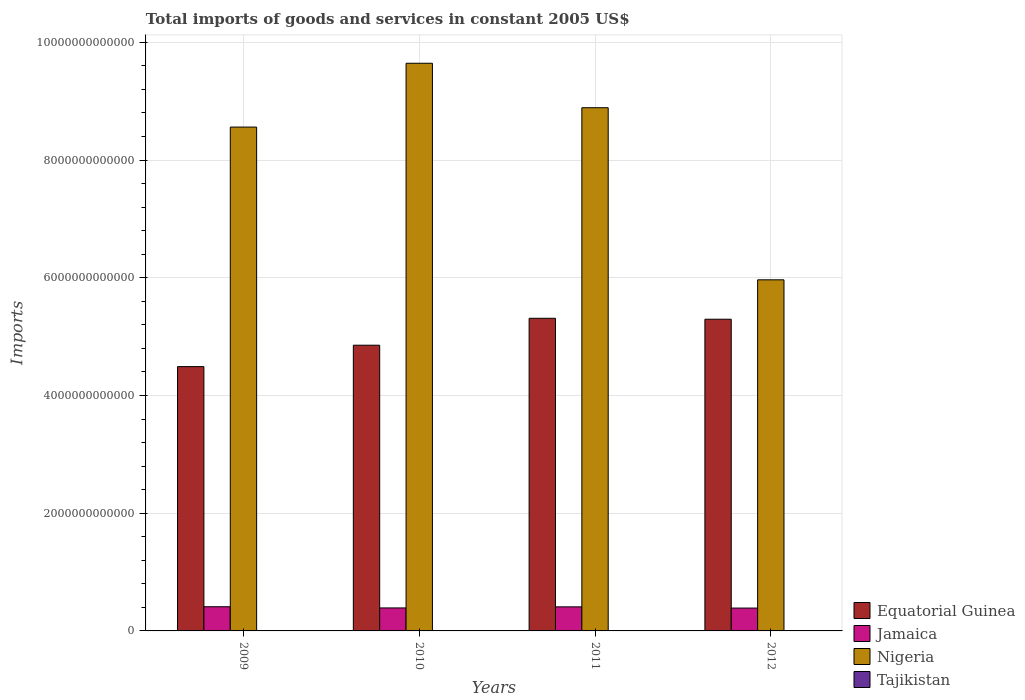How many different coloured bars are there?
Your answer should be very brief. 4. Are the number of bars per tick equal to the number of legend labels?
Make the answer very short. Yes. How many bars are there on the 1st tick from the left?
Offer a terse response. 4. What is the label of the 1st group of bars from the left?
Keep it short and to the point. 2009. What is the total imports of goods and services in Nigeria in 2009?
Provide a succinct answer. 8.56e+12. Across all years, what is the maximum total imports of goods and services in Equatorial Guinea?
Ensure brevity in your answer.  5.31e+12. Across all years, what is the minimum total imports of goods and services in Nigeria?
Make the answer very short. 5.97e+12. In which year was the total imports of goods and services in Jamaica maximum?
Your answer should be compact. 2009. What is the total total imports of goods and services in Tajikistan in the graph?
Make the answer very short. 1.70e+1. What is the difference between the total imports of goods and services in Jamaica in 2010 and that in 2011?
Provide a succinct answer. -1.83e+1. What is the difference between the total imports of goods and services in Nigeria in 2011 and the total imports of goods and services in Equatorial Guinea in 2010?
Offer a terse response. 4.03e+12. What is the average total imports of goods and services in Jamaica per year?
Give a very brief answer. 4.00e+11. In the year 2009, what is the difference between the total imports of goods and services in Equatorial Guinea and total imports of goods and services in Jamaica?
Your answer should be very brief. 4.08e+12. In how many years, is the total imports of goods and services in Nigeria greater than 6800000000000 US$?
Provide a succinct answer. 3. What is the ratio of the total imports of goods and services in Tajikistan in 2009 to that in 2010?
Keep it short and to the point. 0.93. Is the total imports of goods and services in Jamaica in 2009 less than that in 2011?
Provide a succinct answer. No. Is the difference between the total imports of goods and services in Equatorial Guinea in 2009 and 2010 greater than the difference between the total imports of goods and services in Jamaica in 2009 and 2010?
Make the answer very short. No. What is the difference between the highest and the second highest total imports of goods and services in Jamaica?
Provide a short and direct response. 1.80e+09. What is the difference between the highest and the lowest total imports of goods and services in Nigeria?
Your response must be concise. 3.68e+12. In how many years, is the total imports of goods and services in Jamaica greater than the average total imports of goods and services in Jamaica taken over all years?
Provide a succinct answer. 2. What does the 4th bar from the left in 2012 represents?
Offer a very short reply. Tajikistan. What does the 4th bar from the right in 2011 represents?
Make the answer very short. Equatorial Guinea. What is the difference between two consecutive major ticks on the Y-axis?
Your answer should be very brief. 2.00e+12. Where does the legend appear in the graph?
Your response must be concise. Bottom right. What is the title of the graph?
Your response must be concise. Total imports of goods and services in constant 2005 US$. What is the label or title of the X-axis?
Offer a very short reply. Years. What is the label or title of the Y-axis?
Ensure brevity in your answer.  Imports. What is the Imports in Equatorial Guinea in 2009?
Ensure brevity in your answer.  4.49e+12. What is the Imports in Jamaica in 2009?
Ensure brevity in your answer.  4.11e+11. What is the Imports of Nigeria in 2009?
Give a very brief answer. 8.56e+12. What is the Imports in Tajikistan in 2009?
Offer a very short reply. 3.83e+09. What is the Imports of Equatorial Guinea in 2010?
Provide a succinct answer. 4.85e+12. What is the Imports in Jamaica in 2010?
Offer a very short reply. 3.91e+11. What is the Imports in Nigeria in 2010?
Give a very brief answer. 9.64e+12. What is the Imports in Tajikistan in 2010?
Provide a succinct answer. 4.10e+09. What is the Imports of Equatorial Guinea in 2011?
Give a very brief answer. 5.31e+12. What is the Imports of Jamaica in 2011?
Your response must be concise. 4.09e+11. What is the Imports of Nigeria in 2011?
Make the answer very short. 8.89e+12. What is the Imports in Tajikistan in 2011?
Ensure brevity in your answer.  4.38e+09. What is the Imports in Equatorial Guinea in 2012?
Your answer should be very brief. 5.30e+12. What is the Imports in Jamaica in 2012?
Offer a terse response. 3.88e+11. What is the Imports in Nigeria in 2012?
Your response must be concise. 5.97e+12. What is the Imports of Tajikistan in 2012?
Keep it short and to the point. 4.65e+09. Across all years, what is the maximum Imports of Equatorial Guinea?
Ensure brevity in your answer.  5.31e+12. Across all years, what is the maximum Imports in Jamaica?
Keep it short and to the point. 4.11e+11. Across all years, what is the maximum Imports of Nigeria?
Provide a succinct answer. 9.64e+12. Across all years, what is the maximum Imports in Tajikistan?
Offer a very short reply. 4.65e+09. Across all years, what is the minimum Imports in Equatorial Guinea?
Make the answer very short. 4.49e+12. Across all years, what is the minimum Imports in Jamaica?
Provide a short and direct response. 3.88e+11. Across all years, what is the minimum Imports in Nigeria?
Keep it short and to the point. 5.97e+12. Across all years, what is the minimum Imports of Tajikistan?
Provide a short and direct response. 3.83e+09. What is the total Imports of Equatorial Guinea in the graph?
Give a very brief answer. 2.00e+13. What is the total Imports of Jamaica in the graph?
Give a very brief answer. 1.60e+12. What is the total Imports in Nigeria in the graph?
Give a very brief answer. 3.31e+13. What is the total Imports of Tajikistan in the graph?
Your answer should be compact. 1.70e+1. What is the difference between the Imports in Equatorial Guinea in 2009 and that in 2010?
Keep it short and to the point. -3.64e+11. What is the difference between the Imports of Jamaica in 2009 and that in 2010?
Give a very brief answer. 2.01e+1. What is the difference between the Imports in Nigeria in 2009 and that in 2010?
Offer a terse response. -1.08e+12. What is the difference between the Imports of Tajikistan in 2009 and that in 2010?
Your answer should be very brief. -2.73e+08. What is the difference between the Imports of Equatorial Guinea in 2009 and that in 2011?
Give a very brief answer. -8.21e+11. What is the difference between the Imports of Jamaica in 2009 and that in 2011?
Give a very brief answer. 1.80e+09. What is the difference between the Imports of Nigeria in 2009 and that in 2011?
Keep it short and to the point. -3.29e+11. What is the difference between the Imports in Tajikistan in 2009 and that in 2011?
Keep it short and to the point. -5.47e+08. What is the difference between the Imports of Equatorial Guinea in 2009 and that in 2012?
Ensure brevity in your answer.  -8.05e+11. What is the difference between the Imports of Jamaica in 2009 and that in 2012?
Your answer should be very brief. 2.25e+1. What is the difference between the Imports of Nigeria in 2009 and that in 2012?
Ensure brevity in your answer.  2.60e+12. What is the difference between the Imports in Tajikistan in 2009 and that in 2012?
Provide a succinct answer. -8.20e+08. What is the difference between the Imports of Equatorial Guinea in 2010 and that in 2011?
Your response must be concise. -4.57e+11. What is the difference between the Imports of Jamaica in 2010 and that in 2011?
Make the answer very short. -1.83e+1. What is the difference between the Imports in Nigeria in 2010 and that in 2011?
Provide a succinct answer. 7.55e+11. What is the difference between the Imports in Tajikistan in 2010 and that in 2011?
Ensure brevity in your answer.  -2.73e+08. What is the difference between the Imports of Equatorial Guinea in 2010 and that in 2012?
Your answer should be very brief. -4.41e+11. What is the difference between the Imports of Jamaica in 2010 and that in 2012?
Keep it short and to the point. 2.44e+09. What is the difference between the Imports in Nigeria in 2010 and that in 2012?
Ensure brevity in your answer.  3.68e+12. What is the difference between the Imports in Tajikistan in 2010 and that in 2012?
Ensure brevity in your answer.  -5.47e+08. What is the difference between the Imports of Equatorial Guinea in 2011 and that in 2012?
Provide a succinct answer. 1.59e+1. What is the difference between the Imports in Jamaica in 2011 and that in 2012?
Your response must be concise. 2.07e+1. What is the difference between the Imports of Nigeria in 2011 and that in 2012?
Ensure brevity in your answer.  2.92e+12. What is the difference between the Imports in Tajikistan in 2011 and that in 2012?
Your response must be concise. -2.73e+08. What is the difference between the Imports of Equatorial Guinea in 2009 and the Imports of Jamaica in 2010?
Provide a short and direct response. 4.10e+12. What is the difference between the Imports of Equatorial Guinea in 2009 and the Imports of Nigeria in 2010?
Offer a very short reply. -5.15e+12. What is the difference between the Imports of Equatorial Guinea in 2009 and the Imports of Tajikistan in 2010?
Make the answer very short. 4.49e+12. What is the difference between the Imports in Jamaica in 2009 and the Imports in Nigeria in 2010?
Provide a short and direct response. -9.23e+12. What is the difference between the Imports of Jamaica in 2009 and the Imports of Tajikistan in 2010?
Provide a short and direct response. 4.07e+11. What is the difference between the Imports in Nigeria in 2009 and the Imports in Tajikistan in 2010?
Ensure brevity in your answer.  8.56e+12. What is the difference between the Imports in Equatorial Guinea in 2009 and the Imports in Jamaica in 2011?
Your response must be concise. 4.08e+12. What is the difference between the Imports in Equatorial Guinea in 2009 and the Imports in Nigeria in 2011?
Your answer should be very brief. -4.40e+12. What is the difference between the Imports of Equatorial Guinea in 2009 and the Imports of Tajikistan in 2011?
Offer a terse response. 4.49e+12. What is the difference between the Imports of Jamaica in 2009 and the Imports of Nigeria in 2011?
Your answer should be compact. -8.48e+12. What is the difference between the Imports in Jamaica in 2009 and the Imports in Tajikistan in 2011?
Provide a succinct answer. 4.06e+11. What is the difference between the Imports in Nigeria in 2009 and the Imports in Tajikistan in 2011?
Your answer should be very brief. 8.56e+12. What is the difference between the Imports of Equatorial Guinea in 2009 and the Imports of Jamaica in 2012?
Provide a succinct answer. 4.10e+12. What is the difference between the Imports in Equatorial Guinea in 2009 and the Imports in Nigeria in 2012?
Provide a succinct answer. -1.47e+12. What is the difference between the Imports of Equatorial Guinea in 2009 and the Imports of Tajikistan in 2012?
Your response must be concise. 4.49e+12. What is the difference between the Imports in Jamaica in 2009 and the Imports in Nigeria in 2012?
Keep it short and to the point. -5.55e+12. What is the difference between the Imports in Jamaica in 2009 and the Imports in Tajikistan in 2012?
Your answer should be very brief. 4.06e+11. What is the difference between the Imports in Nigeria in 2009 and the Imports in Tajikistan in 2012?
Offer a terse response. 8.56e+12. What is the difference between the Imports of Equatorial Guinea in 2010 and the Imports of Jamaica in 2011?
Ensure brevity in your answer.  4.45e+12. What is the difference between the Imports in Equatorial Guinea in 2010 and the Imports in Nigeria in 2011?
Provide a short and direct response. -4.03e+12. What is the difference between the Imports in Equatorial Guinea in 2010 and the Imports in Tajikistan in 2011?
Your response must be concise. 4.85e+12. What is the difference between the Imports of Jamaica in 2010 and the Imports of Nigeria in 2011?
Provide a succinct answer. -8.50e+12. What is the difference between the Imports in Jamaica in 2010 and the Imports in Tajikistan in 2011?
Your response must be concise. 3.86e+11. What is the difference between the Imports of Nigeria in 2010 and the Imports of Tajikistan in 2011?
Provide a short and direct response. 9.64e+12. What is the difference between the Imports in Equatorial Guinea in 2010 and the Imports in Jamaica in 2012?
Give a very brief answer. 4.47e+12. What is the difference between the Imports of Equatorial Guinea in 2010 and the Imports of Nigeria in 2012?
Your answer should be very brief. -1.11e+12. What is the difference between the Imports in Equatorial Guinea in 2010 and the Imports in Tajikistan in 2012?
Ensure brevity in your answer.  4.85e+12. What is the difference between the Imports of Jamaica in 2010 and the Imports of Nigeria in 2012?
Your answer should be very brief. -5.57e+12. What is the difference between the Imports in Jamaica in 2010 and the Imports in Tajikistan in 2012?
Offer a terse response. 3.86e+11. What is the difference between the Imports in Nigeria in 2010 and the Imports in Tajikistan in 2012?
Offer a terse response. 9.64e+12. What is the difference between the Imports of Equatorial Guinea in 2011 and the Imports of Jamaica in 2012?
Make the answer very short. 4.92e+12. What is the difference between the Imports in Equatorial Guinea in 2011 and the Imports in Nigeria in 2012?
Give a very brief answer. -6.54e+11. What is the difference between the Imports in Equatorial Guinea in 2011 and the Imports in Tajikistan in 2012?
Give a very brief answer. 5.31e+12. What is the difference between the Imports in Jamaica in 2011 and the Imports in Nigeria in 2012?
Offer a terse response. -5.56e+12. What is the difference between the Imports of Jamaica in 2011 and the Imports of Tajikistan in 2012?
Give a very brief answer. 4.04e+11. What is the difference between the Imports of Nigeria in 2011 and the Imports of Tajikistan in 2012?
Make the answer very short. 8.88e+12. What is the average Imports of Equatorial Guinea per year?
Give a very brief answer. 4.99e+12. What is the average Imports of Jamaica per year?
Offer a terse response. 4.00e+11. What is the average Imports in Nigeria per year?
Keep it short and to the point. 8.26e+12. What is the average Imports of Tajikistan per year?
Make the answer very short. 4.24e+09. In the year 2009, what is the difference between the Imports of Equatorial Guinea and Imports of Jamaica?
Keep it short and to the point. 4.08e+12. In the year 2009, what is the difference between the Imports in Equatorial Guinea and Imports in Nigeria?
Your answer should be very brief. -4.07e+12. In the year 2009, what is the difference between the Imports of Equatorial Guinea and Imports of Tajikistan?
Ensure brevity in your answer.  4.49e+12. In the year 2009, what is the difference between the Imports in Jamaica and Imports in Nigeria?
Give a very brief answer. -8.15e+12. In the year 2009, what is the difference between the Imports of Jamaica and Imports of Tajikistan?
Keep it short and to the point. 4.07e+11. In the year 2009, what is the difference between the Imports in Nigeria and Imports in Tajikistan?
Make the answer very short. 8.56e+12. In the year 2010, what is the difference between the Imports of Equatorial Guinea and Imports of Jamaica?
Offer a terse response. 4.46e+12. In the year 2010, what is the difference between the Imports of Equatorial Guinea and Imports of Nigeria?
Offer a terse response. -4.79e+12. In the year 2010, what is the difference between the Imports of Equatorial Guinea and Imports of Tajikistan?
Keep it short and to the point. 4.85e+12. In the year 2010, what is the difference between the Imports of Jamaica and Imports of Nigeria?
Make the answer very short. -9.25e+12. In the year 2010, what is the difference between the Imports in Jamaica and Imports in Tajikistan?
Provide a short and direct response. 3.87e+11. In the year 2010, what is the difference between the Imports of Nigeria and Imports of Tajikistan?
Ensure brevity in your answer.  9.64e+12. In the year 2011, what is the difference between the Imports of Equatorial Guinea and Imports of Jamaica?
Give a very brief answer. 4.90e+12. In the year 2011, what is the difference between the Imports in Equatorial Guinea and Imports in Nigeria?
Your response must be concise. -3.58e+12. In the year 2011, what is the difference between the Imports in Equatorial Guinea and Imports in Tajikistan?
Provide a short and direct response. 5.31e+12. In the year 2011, what is the difference between the Imports of Jamaica and Imports of Nigeria?
Give a very brief answer. -8.48e+12. In the year 2011, what is the difference between the Imports of Jamaica and Imports of Tajikistan?
Your response must be concise. 4.05e+11. In the year 2011, what is the difference between the Imports in Nigeria and Imports in Tajikistan?
Keep it short and to the point. 8.88e+12. In the year 2012, what is the difference between the Imports of Equatorial Guinea and Imports of Jamaica?
Your answer should be very brief. 4.91e+12. In the year 2012, what is the difference between the Imports in Equatorial Guinea and Imports in Nigeria?
Make the answer very short. -6.70e+11. In the year 2012, what is the difference between the Imports in Equatorial Guinea and Imports in Tajikistan?
Your response must be concise. 5.29e+12. In the year 2012, what is the difference between the Imports in Jamaica and Imports in Nigeria?
Your answer should be very brief. -5.58e+12. In the year 2012, what is the difference between the Imports in Jamaica and Imports in Tajikistan?
Offer a very short reply. 3.84e+11. In the year 2012, what is the difference between the Imports of Nigeria and Imports of Tajikistan?
Give a very brief answer. 5.96e+12. What is the ratio of the Imports in Equatorial Guinea in 2009 to that in 2010?
Make the answer very short. 0.93. What is the ratio of the Imports of Jamaica in 2009 to that in 2010?
Ensure brevity in your answer.  1.05. What is the ratio of the Imports in Nigeria in 2009 to that in 2010?
Provide a succinct answer. 0.89. What is the ratio of the Imports in Tajikistan in 2009 to that in 2010?
Provide a short and direct response. 0.93. What is the ratio of the Imports in Equatorial Guinea in 2009 to that in 2011?
Your response must be concise. 0.85. What is the ratio of the Imports in Jamaica in 2009 to that in 2011?
Offer a terse response. 1. What is the ratio of the Imports in Tajikistan in 2009 to that in 2011?
Provide a succinct answer. 0.88. What is the ratio of the Imports of Equatorial Guinea in 2009 to that in 2012?
Offer a very short reply. 0.85. What is the ratio of the Imports of Jamaica in 2009 to that in 2012?
Provide a succinct answer. 1.06. What is the ratio of the Imports in Nigeria in 2009 to that in 2012?
Your response must be concise. 1.44. What is the ratio of the Imports in Tajikistan in 2009 to that in 2012?
Offer a very short reply. 0.82. What is the ratio of the Imports of Equatorial Guinea in 2010 to that in 2011?
Offer a terse response. 0.91. What is the ratio of the Imports in Jamaica in 2010 to that in 2011?
Give a very brief answer. 0.96. What is the ratio of the Imports of Nigeria in 2010 to that in 2011?
Keep it short and to the point. 1.08. What is the ratio of the Imports in Tajikistan in 2010 to that in 2011?
Give a very brief answer. 0.94. What is the ratio of the Imports in Equatorial Guinea in 2010 to that in 2012?
Your answer should be compact. 0.92. What is the ratio of the Imports in Jamaica in 2010 to that in 2012?
Provide a succinct answer. 1.01. What is the ratio of the Imports of Nigeria in 2010 to that in 2012?
Your answer should be very brief. 1.62. What is the ratio of the Imports of Tajikistan in 2010 to that in 2012?
Your answer should be compact. 0.88. What is the ratio of the Imports in Equatorial Guinea in 2011 to that in 2012?
Your response must be concise. 1. What is the ratio of the Imports in Jamaica in 2011 to that in 2012?
Keep it short and to the point. 1.05. What is the ratio of the Imports in Nigeria in 2011 to that in 2012?
Your response must be concise. 1.49. What is the difference between the highest and the second highest Imports of Equatorial Guinea?
Ensure brevity in your answer.  1.59e+1. What is the difference between the highest and the second highest Imports in Jamaica?
Your answer should be very brief. 1.80e+09. What is the difference between the highest and the second highest Imports of Nigeria?
Make the answer very short. 7.55e+11. What is the difference between the highest and the second highest Imports of Tajikistan?
Provide a short and direct response. 2.73e+08. What is the difference between the highest and the lowest Imports in Equatorial Guinea?
Provide a succinct answer. 8.21e+11. What is the difference between the highest and the lowest Imports in Jamaica?
Your answer should be very brief. 2.25e+1. What is the difference between the highest and the lowest Imports of Nigeria?
Give a very brief answer. 3.68e+12. What is the difference between the highest and the lowest Imports in Tajikistan?
Your response must be concise. 8.20e+08. 